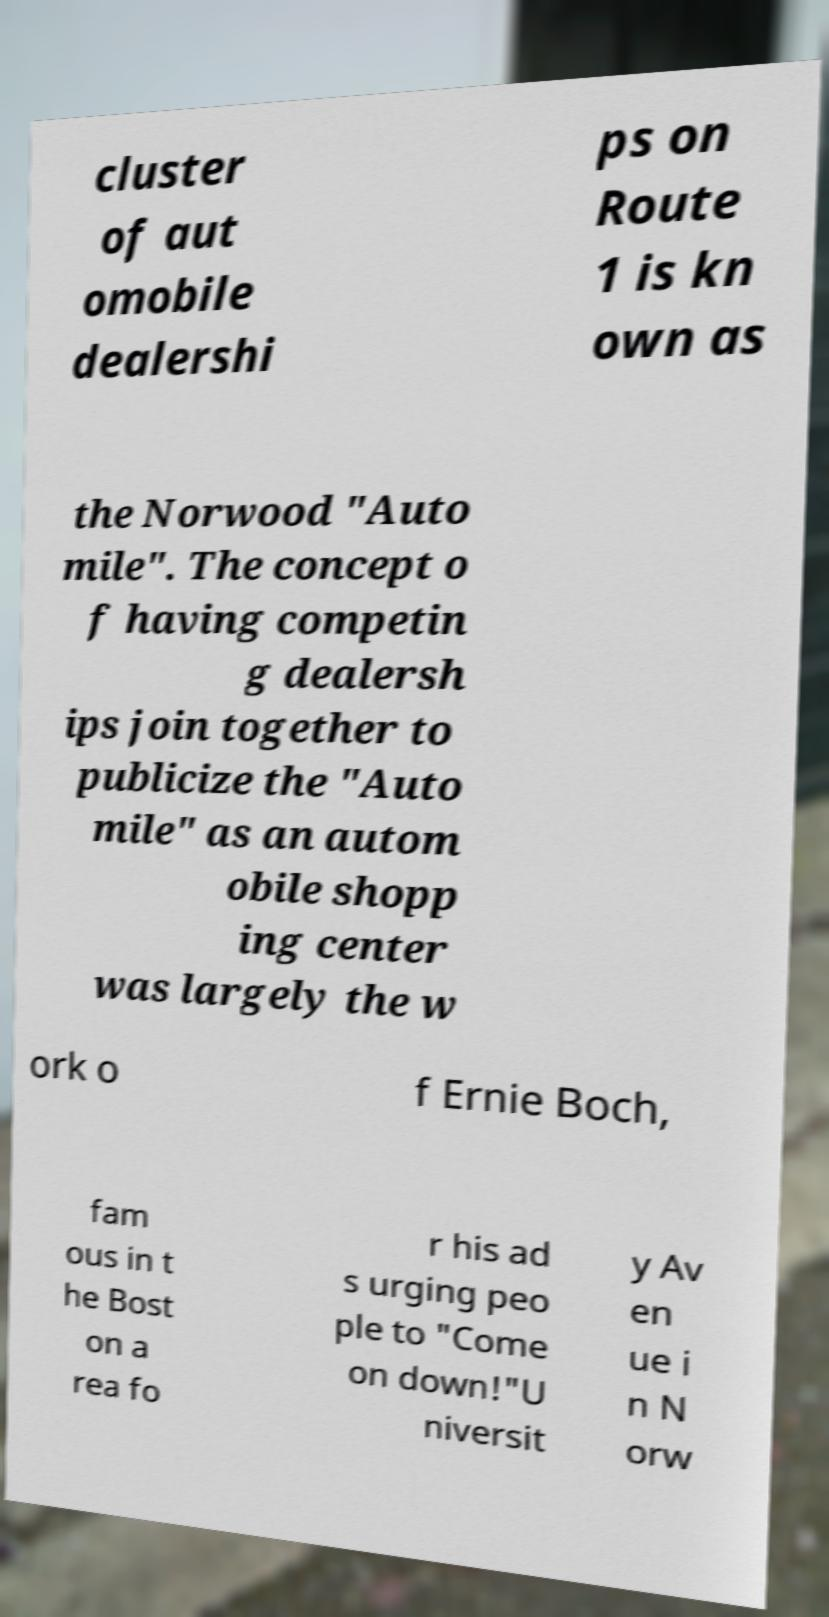Could you assist in decoding the text presented in this image and type it out clearly? cluster of aut omobile dealershi ps on Route 1 is kn own as the Norwood "Auto mile". The concept o f having competin g dealersh ips join together to publicize the "Auto mile" as an autom obile shopp ing center was largely the w ork o f Ernie Boch, fam ous in t he Bost on a rea fo r his ad s urging peo ple to "Come on down!"U niversit y Av en ue i n N orw 